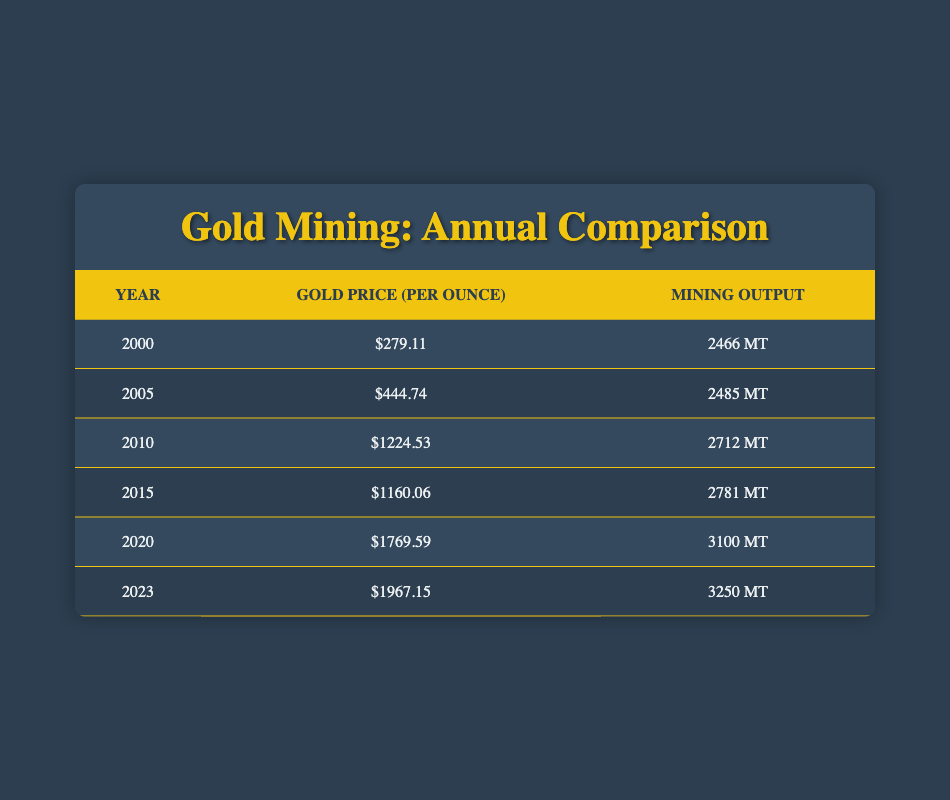What was the gold price per ounce in the year 2010? According to the table, the value listed for the year 2010 in the gold price column is 1224.53.
Answer: 1224.53 How much did mining output increase from the year 2000 to 2023? The mining output for the year 2000 is 2466 metric tons, and for 2023 it is 3250 metric tons. To find the increase, subtract the earlier year from the later year: 3250 - 2466 = 784 metric tons.
Answer: 784 metric tons Was the gold price higher in 2015 than in 2005? The gold price in 2015 is listed as 1160.06, while in 2005 it was 444.74. Since 1160.06 is greater than 444.74, the statement is true.
Answer: Yes What is the average gold price over all the years listed in the table? To find the average gold price, add all the prices together: 279.11 + 444.74 + 1224.53 + 1160.06 + 1769.59 + 1967.15 = 5044.18. There are 6 years total, so divide by 6: 5044.18 / 6 = 840.70.
Answer: 840.70 In which year was the mining output the highest, and what was its value? The table shows that the highest mining output occurs in 2023 at 3250 metric tons. To confirm, compare each row for the maximum value across all years.
Answer: 2023, 3250 metric tons What is the percentage increase in gold price from 2000 to 2023? The gold price in 2000 is 279.11, and in 2023 it is 1967.15. First, find the difference: 1967.15 - 279.11 = 1688.04. Next, divide the difference by the old price: 1688.04 / 279.11 = 6.05. Multiply by 100 to convert to a percentage: 6.05 * 100 = 605.08%.
Answer: 605.08% Did the mining output in 2020 exceed the mining output in 2010? The mining output for 2020 is 3100 metric tons and for 2010 it is 2712 metric tons. Since 3100 exceeds 2712, the statement is true.
Answer: Yes How much did the gold price increase from 2015 to 2020? The gold price in 2015 is 1160.06 and in 2020 it is 1769.59. The increase is calculated by subtracting the earlier price from the later price: 1769.59 - 1160.06 = 609.53.
Answer: 609.53 